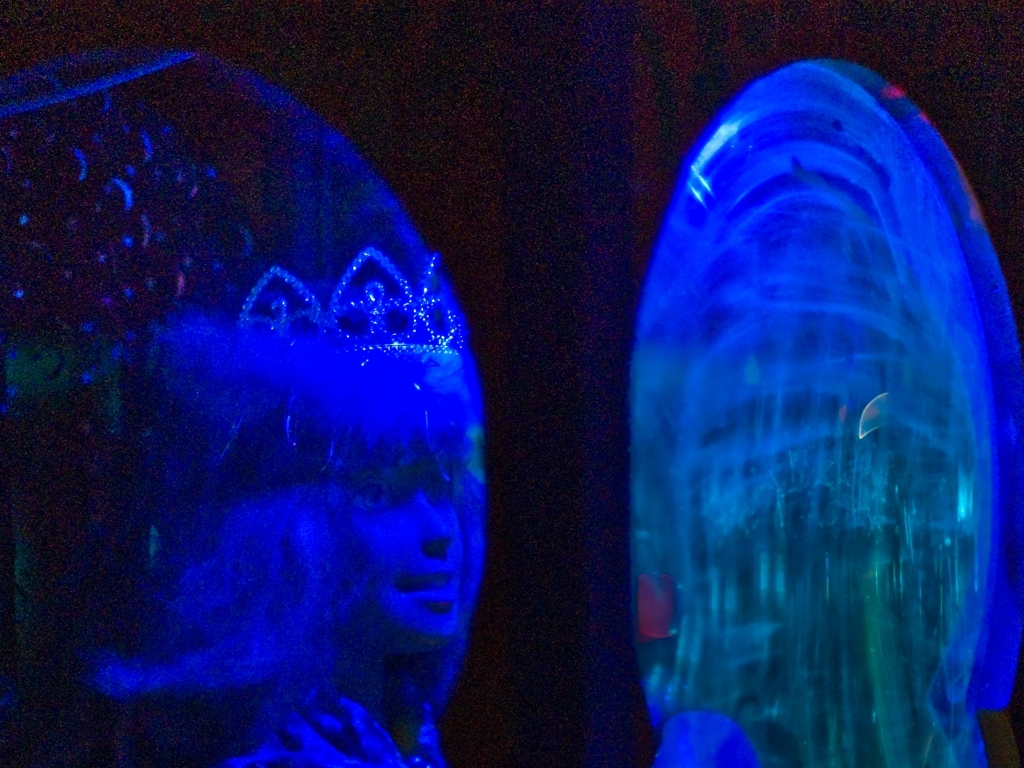What creates the atmospheric look in this photo? The atmospheric look of the photo is primarily due to the interplay of low-light conditions and the artificial blue lighting. This combination often results in a high-contrast composition with pronounced shadows and highlights, contributing to a dreamlike or otherworldly atmosphere in the image. 